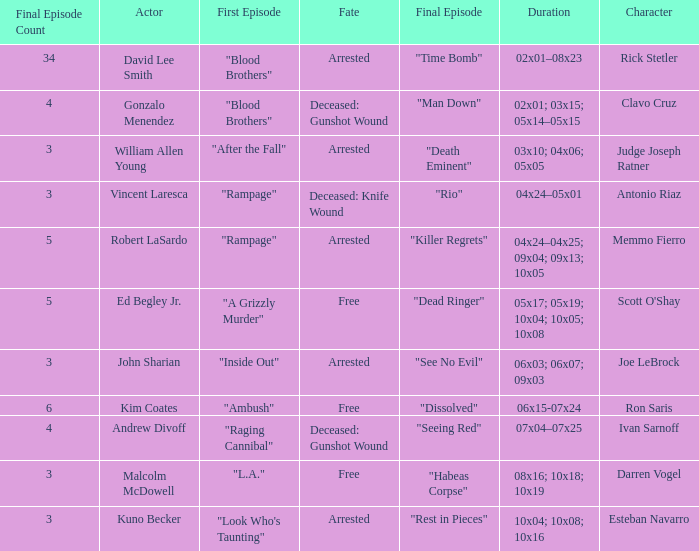What's the actor with character being judge joseph ratner William Allen Young. 